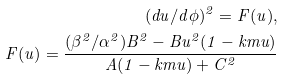<formula> <loc_0><loc_0><loc_500><loc_500>( d u / d \phi ) ^ { 2 } = F ( u ) , \\ F ( u ) = \frac { ( \beta ^ { 2 } / \alpha ^ { 2 } ) B ^ { 2 } - B u ^ { 2 } ( 1 - k m u ) } { A ( 1 - k m u ) + C ^ { 2 } }</formula> 